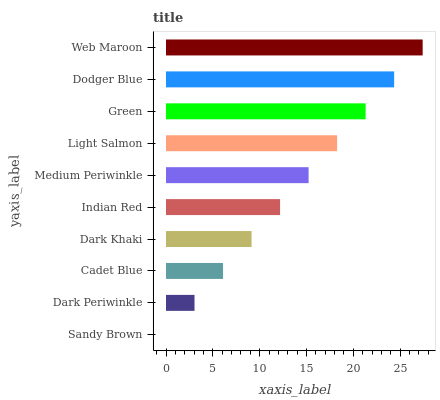Is Sandy Brown the minimum?
Answer yes or no. Yes. Is Web Maroon the maximum?
Answer yes or no. Yes. Is Dark Periwinkle the minimum?
Answer yes or no. No. Is Dark Periwinkle the maximum?
Answer yes or no. No. Is Dark Periwinkle greater than Sandy Brown?
Answer yes or no. Yes. Is Sandy Brown less than Dark Periwinkle?
Answer yes or no. Yes. Is Sandy Brown greater than Dark Periwinkle?
Answer yes or no. No. Is Dark Periwinkle less than Sandy Brown?
Answer yes or no. No. Is Medium Periwinkle the high median?
Answer yes or no. Yes. Is Indian Red the low median?
Answer yes or no. Yes. Is Web Maroon the high median?
Answer yes or no. No. Is Light Salmon the low median?
Answer yes or no. No. 